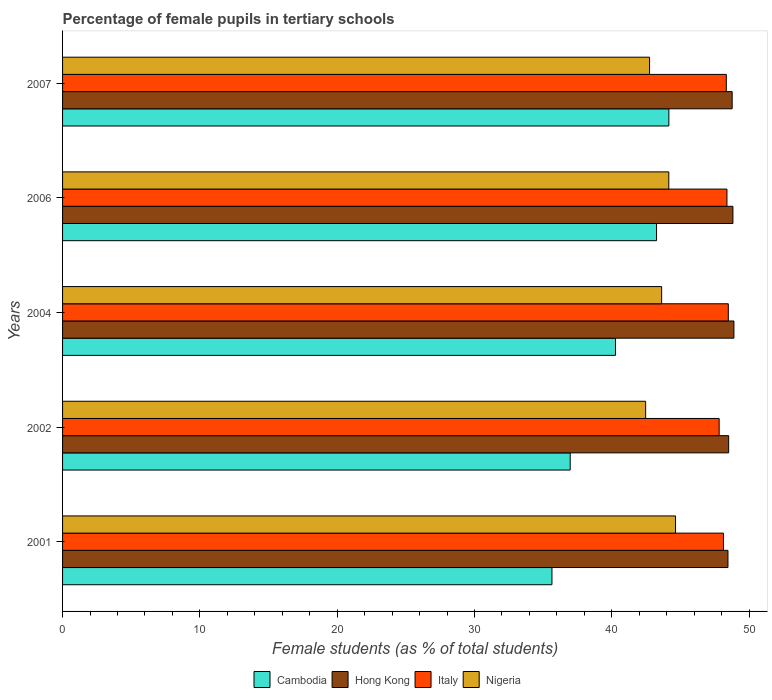How many different coloured bars are there?
Ensure brevity in your answer.  4. How many groups of bars are there?
Your answer should be compact. 5. Are the number of bars per tick equal to the number of legend labels?
Offer a very short reply. Yes. Are the number of bars on each tick of the Y-axis equal?
Your answer should be very brief. Yes. How many bars are there on the 2nd tick from the top?
Your answer should be very brief. 4. How many bars are there on the 5th tick from the bottom?
Your answer should be compact. 4. What is the label of the 5th group of bars from the top?
Make the answer very short. 2001. In how many cases, is the number of bars for a given year not equal to the number of legend labels?
Ensure brevity in your answer.  0. What is the percentage of female pupils in tertiary schools in Hong Kong in 2002?
Your answer should be compact. 48.51. Across all years, what is the maximum percentage of female pupils in tertiary schools in Italy?
Your response must be concise. 48.49. Across all years, what is the minimum percentage of female pupils in tertiary schools in Nigeria?
Your answer should be very brief. 42.47. What is the total percentage of female pupils in tertiary schools in Nigeria in the graph?
Give a very brief answer. 217.65. What is the difference between the percentage of female pupils in tertiary schools in Italy in 2001 and that in 2002?
Provide a succinct answer. 0.32. What is the difference between the percentage of female pupils in tertiary schools in Cambodia in 2007 and the percentage of female pupils in tertiary schools in Nigeria in 2002?
Give a very brief answer. 1.69. What is the average percentage of female pupils in tertiary schools in Cambodia per year?
Keep it short and to the point. 40.06. In the year 2001, what is the difference between the percentage of female pupils in tertiary schools in Nigeria and percentage of female pupils in tertiary schools in Hong Kong?
Provide a succinct answer. -3.82. In how many years, is the percentage of female pupils in tertiary schools in Italy greater than 24 %?
Your response must be concise. 5. What is the ratio of the percentage of female pupils in tertiary schools in Cambodia in 2002 to that in 2004?
Your response must be concise. 0.92. Is the difference between the percentage of female pupils in tertiary schools in Nigeria in 2002 and 2004 greater than the difference between the percentage of female pupils in tertiary schools in Hong Kong in 2002 and 2004?
Ensure brevity in your answer.  No. What is the difference between the highest and the second highest percentage of female pupils in tertiary schools in Hong Kong?
Your answer should be compact. 0.07. What is the difference between the highest and the lowest percentage of female pupils in tertiary schools in Nigeria?
Your response must be concise. 2.18. In how many years, is the percentage of female pupils in tertiary schools in Nigeria greater than the average percentage of female pupils in tertiary schools in Nigeria taken over all years?
Provide a short and direct response. 3. Is the sum of the percentage of female pupils in tertiary schools in Cambodia in 2001 and 2002 greater than the maximum percentage of female pupils in tertiary schools in Hong Kong across all years?
Your answer should be very brief. Yes. What does the 3rd bar from the top in 2004 represents?
Provide a short and direct response. Hong Kong. What does the 1st bar from the bottom in 2002 represents?
Your response must be concise. Cambodia. Is it the case that in every year, the sum of the percentage of female pupils in tertiary schools in Cambodia and percentage of female pupils in tertiary schools in Hong Kong is greater than the percentage of female pupils in tertiary schools in Nigeria?
Give a very brief answer. Yes. How many bars are there?
Ensure brevity in your answer.  20. Are all the bars in the graph horizontal?
Your answer should be compact. Yes. How many years are there in the graph?
Your answer should be compact. 5. What is the difference between two consecutive major ticks on the X-axis?
Your response must be concise. 10. Does the graph contain grids?
Offer a terse response. No. How many legend labels are there?
Give a very brief answer. 4. What is the title of the graph?
Keep it short and to the point. Percentage of female pupils in tertiary schools. Does "Heavily indebted poor countries" appear as one of the legend labels in the graph?
Make the answer very short. No. What is the label or title of the X-axis?
Provide a succinct answer. Female students (as % of total students). What is the Female students (as % of total students) in Cambodia in 2001?
Give a very brief answer. 35.64. What is the Female students (as % of total students) of Hong Kong in 2001?
Give a very brief answer. 48.46. What is the Female students (as % of total students) in Italy in 2001?
Offer a very short reply. 48.14. What is the Female students (as % of total students) of Nigeria in 2001?
Provide a short and direct response. 44.64. What is the Female students (as % of total students) of Cambodia in 2002?
Offer a terse response. 36.97. What is the Female students (as % of total students) in Hong Kong in 2002?
Provide a short and direct response. 48.51. What is the Female students (as % of total students) in Italy in 2002?
Your answer should be very brief. 47.82. What is the Female students (as % of total students) in Nigeria in 2002?
Your response must be concise. 42.47. What is the Female students (as % of total students) in Cambodia in 2004?
Provide a short and direct response. 40.27. What is the Female students (as % of total students) of Hong Kong in 2004?
Make the answer very short. 48.9. What is the Female students (as % of total students) of Italy in 2004?
Offer a terse response. 48.49. What is the Female students (as % of total students) of Nigeria in 2004?
Offer a very short reply. 43.63. What is the Female students (as % of total students) of Cambodia in 2006?
Provide a succinct answer. 43.26. What is the Female students (as % of total students) of Hong Kong in 2006?
Provide a succinct answer. 48.82. What is the Female students (as % of total students) of Italy in 2006?
Your answer should be very brief. 48.39. What is the Female students (as % of total students) of Nigeria in 2006?
Your response must be concise. 44.15. What is the Female students (as % of total students) of Cambodia in 2007?
Your response must be concise. 44.16. What is the Female students (as % of total students) of Hong Kong in 2007?
Your response must be concise. 48.77. What is the Female students (as % of total students) in Italy in 2007?
Your answer should be very brief. 48.34. What is the Female students (as % of total students) in Nigeria in 2007?
Provide a succinct answer. 42.75. Across all years, what is the maximum Female students (as % of total students) of Cambodia?
Your response must be concise. 44.16. Across all years, what is the maximum Female students (as % of total students) in Hong Kong?
Provide a short and direct response. 48.9. Across all years, what is the maximum Female students (as % of total students) of Italy?
Provide a succinct answer. 48.49. Across all years, what is the maximum Female students (as % of total students) in Nigeria?
Provide a short and direct response. 44.64. Across all years, what is the minimum Female students (as % of total students) of Cambodia?
Your answer should be compact. 35.64. Across all years, what is the minimum Female students (as % of total students) of Hong Kong?
Your answer should be very brief. 48.46. Across all years, what is the minimum Female students (as % of total students) in Italy?
Offer a terse response. 47.82. Across all years, what is the minimum Female students (as % of total students) in Nigeria?
Your response must be concise. 42.47. What is the total Female students (as % of total students) in Cambodia in the graph?
Provide a succinct answer. 200.31. What is the total Female students (as % of total students) of Hong Kong in the graph?
Your response must be concise. 243.47. What is the total Female students (as % of total students) of Italy in the graph?
Make the answer very short. 241.18. What is the total Female students (as % of total students) in Nigeria in the graph?
Provide a short and direct response. 217.65. What is the difference between the Female students (as % of total students) of Cambodia in 2001 and that in 2002?
Keep it short and to the point. -1.33. What is the difference between the Female students (as % of total students) in Hong Kong in 2001 and that in 2002?
Ensure brevity in your answer.  -0.05. What is the difference between the Female students (as % of total students) in Italy in 2001 and that in 2002?
Make the answer very short. 0.32. What is the difference between the Female students (as % of total students) in Nigeria in 2001 and that in 2002?
Your response must be concise. 2.18. What is the difference between the Female students (as % of total students) of Cambodia in 2001 and that in 2004?
Your answer should be compact. -4.63. What is the difference between the Female students (as % of total students) in Hong Kong in 2001 and that in 2004?
Your response must be concise. -0.43. What is the difference between the Female students (as % of total students) of Italy in 2001 and that in 2004?
Provide a short and direct response. -0.35. What is the difference between the Female students (as % of total students) in Nigeria in 2001 and that in 2004?
Your answer should be compact. 1.01. What is the difference between the Female students (as % of total students) of Cambodia in 2001 and that in 2006?
Ensure brevity in your answer.  -7.62. What is the difference between the Female students (as % of total students) of Hong Kong in 2001 and that in 2006?
Ensure brevity in your answer.  -0.36. What is the difference between the Female students (as % of total students) in Italy in 2001 and that in 2006?
Provide a short and direct response. -0.25. What is the difference between the Female students (as % of total students) of Nigeria in 2001 and that in 2006?
Provide a succinct answer. 0.49. What is the difference between the Female students (as % of total students) of Cambodia in 2001 and that in 2007?
Offer a very short reply. -8.51. What is the difference between the Female students (as % of total students) of Hong Kong in 2001 and that in 2007?
Provide a succinct answer. -0.31. What is the difference between the Female students (as % of total students) of Italy in 2001 and that in 2007?
Your answer should be very brief. -0.21. What is the difference between the Female students (as % of total students) in Nigeria in 2001 and that in 2007?
Offer a very short reply. 1.89. What is the difference between the Female students (as % of total students) in Cambodia in 2002 and that in 2004?
Your answer should be very brief. -3.3. What is the difference between the Female students (as % of total students) in Hong Kong in 2002 and that in 2004?
Offer a terse response. -0.38. What is the difference between the Female students (as % of total students) in Italy in 2002 and that in 2004?
Ensure brevity in your answer.  -0.67. What is the difference between the Female students (as % of total students) of Nigeria in 2002 and that in 2004?
Make the answer very short. -1.16. What is the difference between the Female students (as % of total students) in Cambodia in 2002 and that in 2006?
Your answer should be compact. -6.29. What is the difference between the Female students (as % of total students) in Hong Kong in 2002 and that in 2006?
Offer a very short reply. -0.31. What is the difference between the Female students (as % of total students) in Italy in 2002 and that in 2006?
Your response must be concise. -0.57. What is the difference between the Female students (as % of total students) in Nigeria in 2002 and that in 2006?
Offer a terse response. -1.69. What is the difference between the Female students (as % of total students) in Cambodia in 2002 and that in 2007?
Offer a terse response. -7.19. What is the difference between the Female students (as % of total students) in Hong Kong in 2002 and that in 2007?
Your response must be concise. -0.25. What is the difference between the Female students (as % of total students) in Italy in 2002 and that in 2007?
Keep it short and to the point. -0.52. What is the difference between the Female students (as % of total students) in Nigeria in 2002 and that in 2007?
Give a very brief answer. -0.29. What is the difference between the Female students (as % of total students) of Cambodia in 2004 and that in 2006?
Provide a succinct answer. -2.99. What is the difference between the Female students (as % of total students) in Hong Kong in 2004 and that in 2006?
Your answer should be very brief. 0.07. What is the difference between the Female students (as % of total students) of Italy in 2004 and that in 2006?
Your answer should be very brief. 0.1. What is the difference between the Female students (as % of total students) of Nigeria in 2004 and that in 2006?
Your answer should be very brief. -0.52. What is the difference between the Female students (as % of total students) in Cambodia in 2004 and that in 2007?
Offer a terse response. -3.89. What is the difference between the Female students (as % of total students) of Hong Kong in 2004 and that in 2007?
Your response must be concise. 0.13. What is the difference between the Female students (as % of total students) of Italy in 2004 and that in 2007?
Provide a succinct answer. 0.15. What is the difference between the Female students (as % of total students) in Nigeria in 2004 and that in 2007?
Provide a short and direct response. 0.88. What is the difference between the Female students (as % of total students) of Cambodia in 2006 and that in 2007?
Your response must be concise. -0.9. What is the difference between the Female students (as % of total students) in Hong Kong in 2006 and that in 2007?
Offer a very short reply. 0.06. What is the difference between the Female students (as % of total students) in Italy in 2006 and that in 2007?
Give a very brief answer. 0.05. What is the difference between the Female students (as % of total students) of Nigeria in 2006 and that in 2007?
Keep it short and to the point. 1.4. What is the difference between the Female students (as % of total students) of Cambodia in 2001 and the Female students (as % of total students) of Hong Kong in 2002?
Offer a very short reply. -12.87. What is the difference between the Female students (as % of total students) of Cambodia in 2001 and the Female students (as % of total students) of Italy in 2002?
Ensure brevity in your answer.  -12.18. What is the difference between the Female students (as % of total students) of Cambodia in 2001 and the Female students (as % of total students) of Nigeria in 2002?
Your answer should be very brief. -6.82. What is the difference between the Female students (as % of total students) of Hong Kong in 2001 and the Female students (as % of total students) of Italy in 2002?
Provide a succinct answer. 0.64. What is the difference between the Female students (as % of total students) of Hong Kong in 2001 and the Female students (as % of total students) of Nigeria in 2002?
Provide a short and direct response. 6. What is the difference between the Female students (as % of total students) in Italy in 2001 and the Female students (as % of total students) in Nigeria in 2002?
Your answer should be very brief. 5.67. What is the difference between the Female students (as % of total students) in Cambodia in 2001 and the Female students (as % of total students) in Hong Kong in 2004?
Offer a very short reply. -13.25. What is the difference between the Female students (as % of total students) in Cambodia in 2001 and the Female students (as % of total students) in Italy in 2004?
Your answer should be compact. -12.84. What is the difference between the Female students (as % of total students) of Cambodia in 2001 and the Female students (as % of total students) of Nigeria in 2004?
Your answer should be compact. -7.99. What is the difference between the Female students (as % of total students) in Hong Kong in 2001 and the Female students (as % of total students) in Italy in 2004?
Provide a short and direct response. -0.02. What is the difference between the Female students (as % of total students) in Hong Kong in 2001 and the Female students (as % of total students) in Nigeria in 2004?
Provide a succinct answer. 4.83. What is the difference between the Female students (as % of total students) in Italy in 2001 and the Female students (as % of total students) in Nigeria in 2004?
Your response must be concise. 4.5. What is the difference between the Female students (as % of total students) in Cambodia in 2001 and the Female students (as % of total students) in Hong Kong in 2006?
Provide a short and direct response. -13.18. What is the difference between the Female students (as % of total students) in Cambodia in 2001 and the Female students (as % of total students) in Italy in 2006?
Make the answer very short. -12.75. What is the difference between the Female students (as % of total students) in Cambodia in 2001 and the Female students (as % of total students) in Nigeria in 2006?
Your response must be concise. -8.51. What is the difference between the Female students (as % of total students) of Hong Kong in 2001 and the Female students (as % of total students) of Italy in 2006?
Your answer should be compact. 0.07. What is the difference between the Female students (as % of total students) in Hong Kong in 2001 and the Female students (as % of total students) in Nigeria in 2006?
Offer a terse response. 4.31. What is the difference between the Female students (as % of total students) of Italy in 2001 and the Female students (as % of total students) of Nigeria in 2006?
Offer a very short reply. 3.98. What is the difference between the Female students (as % of total students) of Cambodia in 2001 and the Female students (as % of total students) of Hong Kong in 2007?
Ensure brevity in your answer.  -13.13. What is the difference between the Female students (as % of total students) in Cambodia in 2001 and the Female students (as % of total students) in Italy in 2007?
Your answer should be compact. -12.7. What is the difference between the Female students (as % of total students) of Cambodia in 2001 and the Female students (as % of total students) of Nigeria in 2007?
Give a very brief answer. -7.11. What is the difference between the Female students (as % of total students) in Hong Kong in 2001 and the Female students (as % of total students) in Italy in 2007?
Your answer should be very brief. 0.12. What is the difference between the Female students (as % of total students) of Hong Kong in 2001 and the Female students (as % of total students) of Nigeria in 2007?
Provide a succinct answer. 5.71. What is the difference between the Female students (as % of total students) in Italy in 2001 and the Female students (as % of total students) in Nigeria in 2007?
Make the answer very short. 5.38. What is the difference between the Female students (as % of total students) of Cambodia in 2002 and the Female students (as % of total students) of Hong Kong in 2004?
Ensure brevity in your answer.  -11.92. What is the difference between the Female students (as % of total students) in Cambodia in 2002 and the Female students (as % of total students) in Italy in 2004?
Offer a terse response. -11.52. What is the difference between the Female students (as % of total students) in Cambodia in 2002 and the Female students (as % of total students) in Nigeria in 2004?
Keep it short and to the point. -6.66. What is the difference between the Female students (as % of total students) of Hong Kong in 2002 and the Female students (as % of total students) of Italy in 2004?
Offer a very short reply. 0.03. What is the difference between the Female students (as % of total students) of Hong Kong in 2002 and the Female students (as % of total students) of Nigeria in 2004?
Your answer should be compact. 4.88. What is the difference between the Female students (as % of total students) of Italy in 2002 and the Female students (as % of total students) of Nigeria in 2004?
Your response must be concise. 4.19. What is the difference between the Female students (as % of total students) of Cambodia in 2002 and the Female students (as % of total students) of Hong Kong in 2006?
Offer a terse response. -11.85. What is the difference between the Female students (as % of total students) in Cambodia in 2002 and the Female students (as % of total students) in Italy in 2006?
Offer a very short reply. -11.42. What is the difference between the Female students (as % of total students) of Cambodia in 2002 and the Female students (as % of total students) of Nigeria in 2006?
Your answer should be very brief. -7.18. What is the difference between the Female students (as % of total students) in Hong Kong in 2002 and the Female students (as % of total students) in Italy in 2006?
Offer a very short reply. 0.13. What is the difference between the Female students (as % of total students) in Hong Kong in 2002 and the Female students (as % of total students) in Nigeria in 2006?
Ensure brevity in your answer.  4.36. What is the difference between the Female students (as % of total students) in Italy in 2002 and the Female students (as % of total students) in Nigeria in 2006?
Offer a terse response. 3.67. What is the difference between the Female students (as % of total students) in Cambodia in 2002 and the Female students (as % of total students) in Hong Kong in 2007?
Ensure brevity in your answer.  -11.8. What is the difference between the Female students (as % of total students) in Cambodia in 2002 and the Female students (as % of total students) in Italy in 2007?
Provide a short and direct response. -11.37. What is the difference between the Female students (as % of total students) in Cambodia in 2002 and the Female students (as % of total students) in Nigeria in 2007?
Your response must be concise. -5.78. What is the difference between the Female students (as % of total students) of Hong Kong in 2002 and the Female students (as % of total students) of Italy in 2007?
Ensure brevity in your answer.  0.17. What is the difference between the Female students (as % of total students) of Hong Kong in 2002 and the Female students (as % of total students) of Nigeria in 2007?
Offer a very short reply. 5.76. What is the difference between the Female students (as % of total students) in Italy in 2002 and the Female students (as % of total students) in Nigeria in 2007?
Provide a succinct answer. 5.07. What is the difference between the Female students (as % of total students) in Cambodia in 2004 and the Female students (as % of total students) in Hong Kong in 2006?
Provide a succinct answer. -8.55. What is the difference between the Female students (as % of total students) in Cambodia in 2004 and the Female students (as % of total students) in Italy in 2006?
Provide a short and direct response. -8.12. What is the difference between the Female students (as % of total students) in Cambodia in 2004 and the Female students (as % of total students) in Nigeria in 2006?
Offer a terse response. -3.88. What is the difference between the Female students (as % of total students) of Hong Kong in 2004 and the Female students (as % of total students) of Italy in 2006?
Make the answer very short. 0.51. What is the difference between the Female students (as % of total students) in Hong Kong in 2004 and the Female students (as % of total students) in Nigeria in 2006?
Offer a very short reply. 4.74. What is the difference between the Female students (as % of total students) in Italy in 2004 and the Female students (as % of total students) in Nigeria in 2006?
Your response must be concise. 4.33. What is the difference between the Female students (as % of total students) in Cambodia in 2004 and the Female students (as % of total students) in Hong Kong in 2007?
Your answer should be very brief. -8.5. What is the difference between the Female students (as % of total students) in Cambodia in 2004 and the Female students (as % of total students) in Italy in 2007?
Your answer should be compact. -8.07. What is the difference between the Female students (as % of total students) in Cambodia in 2004 and the Female students (as % of total students) in Nigeria in 2007?
Your response must be concise. -2.48. What is the difference between the Female students (as % of total students) of Hong Kong in 2004 and the Female students (as % of total students) of Italy in 2007?
Your response must be concise. 0.55. What is the difference between the Female students (as % of total students) in Hong Kong in 2004 and the Female students (as % of total students) in Nigeria in 2007?
Provide a short and direct response. 6.14. What is the difference between the Female students (as % of total students) in Italy in 2004 and the Female students (as % of total students) in Nigeria in 2007?
Provide a short and direct response. 5.74. What is the difference between the Female students (as % of total students) of Cambodia in 2006 and the Female students (as % of total students) of Hong Kong in 2007?
Offer a very short reply. -5.51. What is the difference between the Female students (as % of total students) in Cambodia in 2006 and the Female students (as % of total students) in Italy in 2007?
Your answer should be compact. -5.08. What is the difference between the Female students (as % of total students) in Cambodia in 2006 and the Female students (as % of total students) in Nigeria in 2007?
Provide a short and direct response. 0.51. What is the difference between the Female students (as % of total students) of Hong Kong in 2006 and the Female students (as % of total students) of Italy in 2007?
Offer a very short reply. 0.48. What is the difference between the Female students (as % of total students) of Hong Kong in 2006 and the Female students (as % of total students) of Nigeria in 2007?
Your answer should be very brief. 6.07. What is the difference between the Female students (as % of total students) in Italy in 2006 and the Female students (as % of total students) in Nigeria in 2007?
Your answer should be compact. 5.64. What is the average Female students (as % of total students) of Cambodia per year?
Make the answer very short. 40.06. What is the average Female students (as % of total students) of Hong Kong per year?
Your answer should be very brief. 48.69. What is the average Female students (as % of total students) in Italy per year?
Keep it short and to the point. 48.24. What is the average Female students (as % of total students) of Nigeria per year?
Your response must be concise. 43.53. In the year 2001, what is the difference between the Female students (as % of total students) of Cambodia and Female students (as % of total students) of Hong Kong?
Your answer should be very brief. -12.82. In the year 2001, what is the difference between the Female students (as % of total students) of Cambodia and Female students (as % of total students) of Italy?
Your response must be concise. -12.49. In the year 2001, what is the difference between the Female students (as % of total students) in Cambodia and Female students (as % of total students) in Nigeria?
Offer a terse response. -9. In the year 2001, what is the difference between the Female students (as % of total students) of Hong Kong and Female students (as % of total students) of Italy?
Your response must be concise. 0.33. In the year 2001, what is the difference between the Female students (as % of total students) of Hong Kong and Female students (as % of total students) of Nigeria?
Offer a terse response. 3.82. In the year 2001, what is the difference between the Female students (as % of total students) of Italy and Female students (as % of total students) of Nigeria?
Make the answer very short. 3.49. In the year 2002, what is the difference between the Female students (as % of total students) of Cambodia and Female students (as % of total students) of Hong Kong?
Give a very brief answer. -11.54. In the year 2002, what is the difference between the Female students (as % of total students) in Cambodia and Female students (as % of total students) in Italy?
Provide a succinct answer. -10.85. In the year 2002, what is the difference between the Female students (as % of total students) of Cambodia and Female students (as % of total students) of Nigeria?
Offer a very short reply. -5.49. In the year 2002, what is the difference between the Female students (as % of total students) of Hong Kong and Female students (as % of total students) of Italy?
Your answer should be very brief. 0.69. In the year 2002, what is the difference between the Female students (as % of total students) in Hong Kong and Female students (as % of total students) in Nigeria?
Offer a very short reply. 6.05. In the year 2002, what is the difference between the Female students (as % of total students) of Italy and Female students (as % of total students) of Nigeria?
Your answer should be compact. 5.35. In the year 2004, what is the difference between the Female students (as % of total students) in Cambodia and Female students (as % of total students) in Hong Kong?
Offer a terse response. -8.63. In the year 2004, what is the difference between the Female students (as % of total students) of Cambodia and Female students (as % of total students) of Italy?
Your response must be concise. -8.22. In the year 2004, what is the difference between the Female students (as % of total students) of Cambodia and Female students (as % of total students) of Nigeria?
Your response must be concise. -3.36. In the year 2004, what is the difference between the Female students (as % of total students) of Hong Kong and Female students (as % of total students) of Italy?
Provide a short and direct response. 0.41. In the year 2004, what is the difference between the Female students (as % of total students) of Hong Kong and Female students (as % of total students) of Nigeria?
Offer a terse response. 5.26. In the year 2004, what is the difference between the Female students (as % of total students) of Italy and Female students (as % of total students) of Nigeria?
Provide a short and direct response. 4.86. In the year 2006, what is the difference between the Female students (as % of total students) of Cambodia and Female students (as % of total students) of Hong Kong?
Your answer should be compact. -5.56. In the year 2006, what is the difference between the Female students (as % of total students) in Cambodia and Female students (as % of total students) in Italy?
Your answer should be compact. -5.13. In the year 2006, what is the difference between the Female students (as % of total students) in Cambodia and Female students (as % of total students) in Nigeria?
Keep it short and to the point. -0.89. In the year 2006, what is the difference between the Female students (as % of total students) of Hong Kong and Female students (as % of total students) of Italy?
Make the answer very short. 0.43. In the year 2006, what is the difference between the Female students (as % of total students) of Hong Kong and Female students (as % of total students) of Nigeria?
Provide a short and direct response. 4.67. In the year 2006, what is the difference between the Female students (as % of total students) of Italy and Female students (as % of total students) of Nigeria?
Offer a terse response. 4.24. In the year 2007, what is the difference between the Female students (as % of total students) in Cambodia and Female students (as % of total students) in Hong Kong?
Offer a terse response. -4.61. In the year 2007, what is the difference between the Female students (as % of total students) in Cambodia and Female students (as % of total students) in Italy?
Keep it short and to the point. -4.18. In the year 2007, what is the difference between the Female students (as % of total students) of Cambodia and Female students (as % of total students) of Nigeria?
Give a very brief answer. 1.41. In the year 2007, what is the difference between the Female students (as % of total students) of Hong Kong and Female students (as % of total students) of Italy?
Provide a succinct answer. 0.43. In the year 2007, what is the difference between the Female students (as % of total students) in Hong Kong and Female students (as % of total students) in Nigeria?
Provide a succinct answer. 6.02. In the year 2007, what is the difference between the Female students (as % of total students) in Italy and Female students (as % of total students) in Nigeria?
Offer a very short reply. 5.59. What is the ratio of the Female students (as % of total students) in Cambodia in 2001 to that in 2002?
Keep it short and to the point. 0.96. What is the ratio of the Female students (as % of total students) of Hong Kong in 2001 to that in 2002?
Provide a short and direct response. 1. What is the ratio of the Female students (as % of total students) in Italy in 2001 to that in 2002?
Offer a very short reply. 1.01. What is the ratio of the Female students (as % of total students) of Nigeria in 2001 to that in 2002?
Make the answer very short. 1.05. What is the ratio of the Female students (as % of total students) in Cambodia in 2001 to that in 2004?
Provide a succinct answer. 0.89. What is the ratio of the Female students (as % of total students) in Hong Kong in 2001 to that in 2004?
Your response must be concise. 0.99. What is the ratio of the Female students (as % of total students) in Nigeria in 2001 to that in 2004?
Your answer should be very brief. 1.02. What is the ratio of the Female students (as % of total students) in Cambodia in 2001 to that in 2006?
Make the answer very short. 0.82. What is the ratio of the Female students (as % of total students) of Hong Kong in 2001 to that in 2006?
Provide a succinct answer. 0.99. What is the ratio of the Female students (as % of total students) of Nigeria in 2001 to that in 2006?
Make the answer very short. 1.01. What is the ratio of the Female students (as % of total students) in Cambodia in 2001 to that in 2007?
Make the answer very short. 0.81. What is the ratio of the Female students (as % of total students) of Nigeria in 2001 to that in 2007?
Offer a terse response. 1.04. What is the ratio of the Female students (as % of total students) in Cambodia in 2002 to that in 2004?
Offer a terse response. 0.92. What is the ratio of the Female students (as % of total students) of Hong Kong in 2002 to that in 2004?
Offer a very short reply. 0.99. What is the ratio of the Female students (as % of total students) of Italy in 2002 to that in 2004?
Provide a succinct answer. 0.99. What is the ratio of the Female students (as % of total students) in Nigeria in 2002 to that in 2004?
Your answer should be very brief. 0.97. What is the ratio of the Female students (as % of total students) in Cambodia in 2002 to that in 2006?
Make the answer very short. 0.85. What is the ratio of the Female students (as % of total students) in Hong Kong in 2002 to that in 2006?
Provide a succinct answer. 0.99. What is the ratio of the Female students (as % of total students) of Italy in 2002 to that in 2006?
Provide a succinct answer. 0.99. What is the ratio of the Female students (as % of total students) in Nigeria in 2002 to that in 2006?
Offer a very short reply. 0.96. What is the ratio of the Female students (as % of total students) of Cambodia in 2002 to that in 2007?
Offer a very short reply. 0.84. What is the ratio of the Female students (as % of total students) of Hong Kong in 2002 to that in 2007?
Give a very brief answer. 0.99. What is the ratio of the Female students (as % of total students) of Italy in 2002 to that in 2007?
Your answer should be compact. 0.99. What is the ratio of the Female students (as % of total students) in Nigeria in 2002 to that in 2007?
Offer a terse response. 0.99. What is the ratio of the Female students (as % of total students) of Cambodia in 2004 to that in 2006?
Keep it short and to the point. 0.93. What is the ratio of the Female students (as % of total students) in Nigeria in 2004 to that in 2006?
Offer a terse response. 0.99. What is the ratio of the Female students (as % of total students) of Cambodia in 2004 to that in 2007?
Offer a terse response. 0.91. What is the ratio of the Female students (as % of total students) of Italy in 2004 to that in 2007?
Offer a very short reply. 1. What is the ratio of the Female students (as % of total students) in Nigeria in 2004 to that in 2007?
Keep it short and to the point. 1.02. What is the ratio of the Female students (as % of total students) of Cambodia in 2006 to that in 2007?
Offer a very short reply. 0.98. What is the ratio of the Female students (as % of total students) of Italy in 2006 to that in 2007?
Give a very brief answer. 1. What is the ratio of the Female students (as % of total students) in Nigeria in 2006 to that in 2007?
Make the answer very short. 1.03. What is the difference between the highest and the second highest Female students (as % of total students) in Cambodia?
Make the answer very short. 0.9. What is the difference between the highest and the second highest Female students (as % of total students) in Hong Kong?
Provide a succinct answer. 0.07. What is the difference between the highest and the second highest Female students (as % of total students) in Italy?
Offer a terse response. 0.1. What is the difference between the highest and the second highest Female students (as % of total students) of Nigeria?
Offer a very short reply. 0.49. What is the difference between the highest and the lowest Female students (as % of total students) of Cambodia?
Offer a terse response. 8.51. What is the difference between the highest and the lowest Female students (as % of total students) in Hong Kong?
Offer a terse response. 0.43. What is the difference between the highest and the lowest Female students (as % of total students) of Italy?
Your response must be concise. 0.67. What is the difference between the highest and the lowest Female students (as % of total students) in Nigeria?
Make the answer very short. 2.18. 